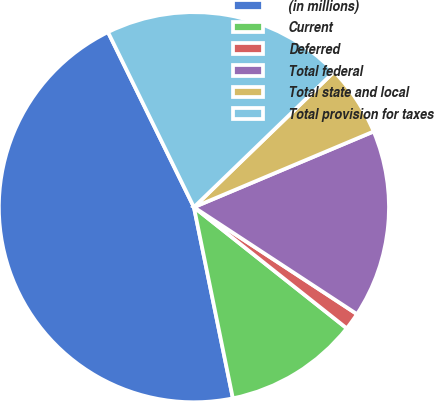<chart> <loc_0><loc_0><loc_500><loc_500><pie_chart><fcel>(in millions)<fcel>Current<fcel>Deferred<fcel>Total federal<fcel>Total state and local<fcel>Total provision for taxes<nl><fcel>45.93%<fcel>11.13%<fcel>1.43%<fcel>15.58%<fcel>5.88%<fcel>20.03%<nl></chart> 